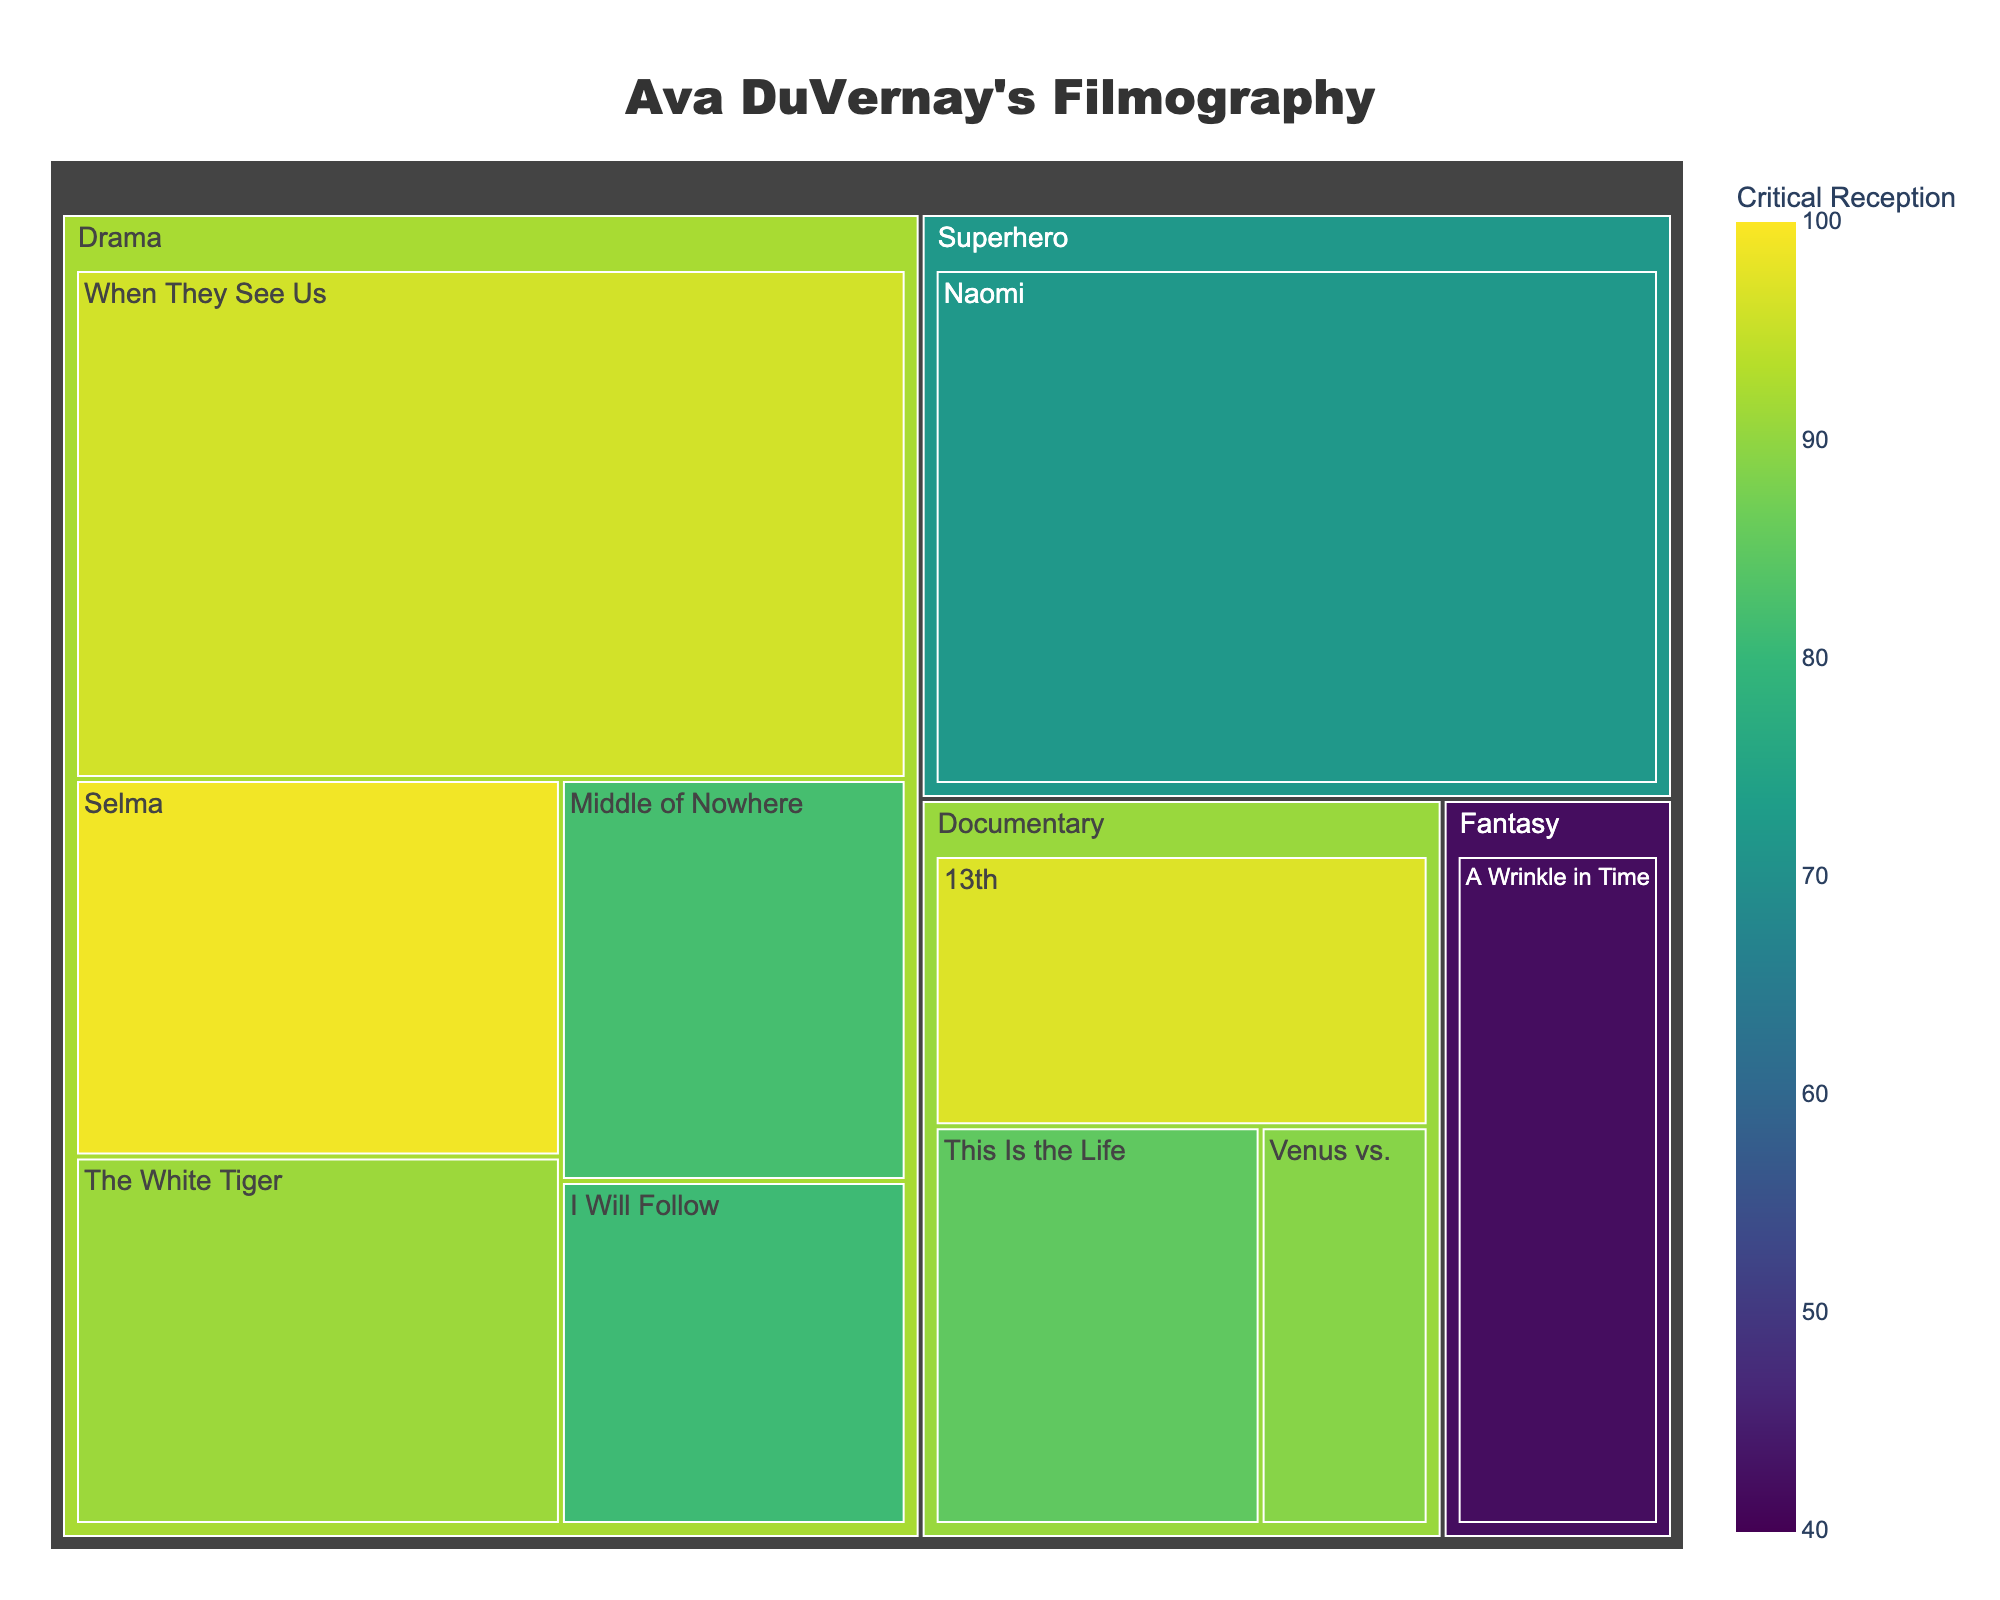What is the title of the treemap? The title of the treemap can be found at the top center of the figure. It states the main subject of the visualization.
Answer: "Ava DuVernay's Filmography" Which genre has the highest total runtime? Observing the size of the areas corresponding to each genre, the Drama genre shows the largest area, indicating the highest total runtime.
Answer: Drama How many films are categorized under the Documentary genre? The Documentary genre section contains multiple films. Counting the individual boxes within the Documentary area gives the total number of films.
Answer: 3 What is the runtime of "Selma"? By hovering over or specifically checking the section for the film "Selma" under the Drama genre, the runtime is displayed in the hover data.
Answer: 128 minutes Which film has the lowest critical reception score? By examining the color intensity and hover data of each film, the film with the darkest shade (indicative of the lowest score) is identified.
Answer: "A Wrinkle in Time" Compare the critical reception scores of "13th" and "Naomi." Which one received a higher score? By locating both films within their respective genres (Documentary for "13th" and Superhero for "Naomi") and comparing their critical reception scores through color intensity or hover data, the higher score can be determined.
Answer: "13th" (97) What is the difference in runtime between "When They See Us" and "Naomi"? Finding the runtime for both films and calculating the difference: Runtime of "When They See Us" (296) - Runtime of "Naomi" (282).
Answer: 14 minutes Which genre has the highest average critical reception score? Calculating the average critical reception score for each genre by summing their critical receptions and dividing by the number of films, then comparing the averages. Detailed calculations are required.
Answer: Documentary (with an average score of approximately 90.33) How many films have a runtime greater than 100 minutes? By scanning through the hover data of each film and counting those with a runtime surpassing 100 minutes.
Answer: 5 